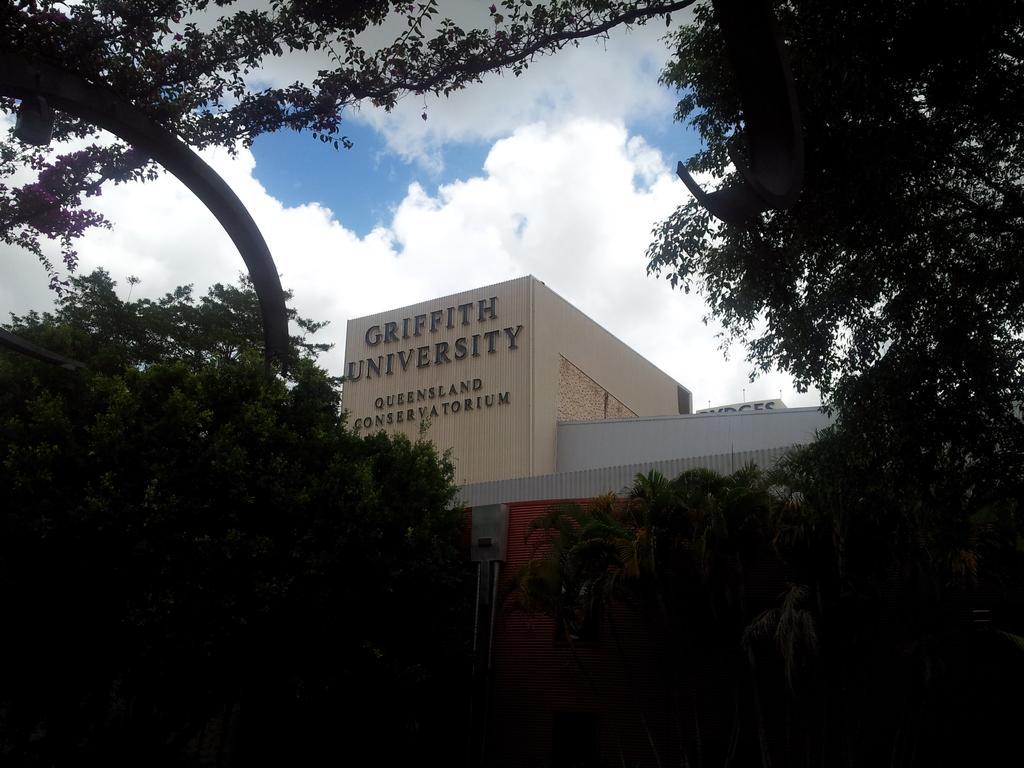Describe this image in one or two sentences. In this image we can see a building and there is a text on the wall and we can see some trees and there is a metal rod at the top. We can see the creepers and flowers at the top and we can see the sky with clouds. 